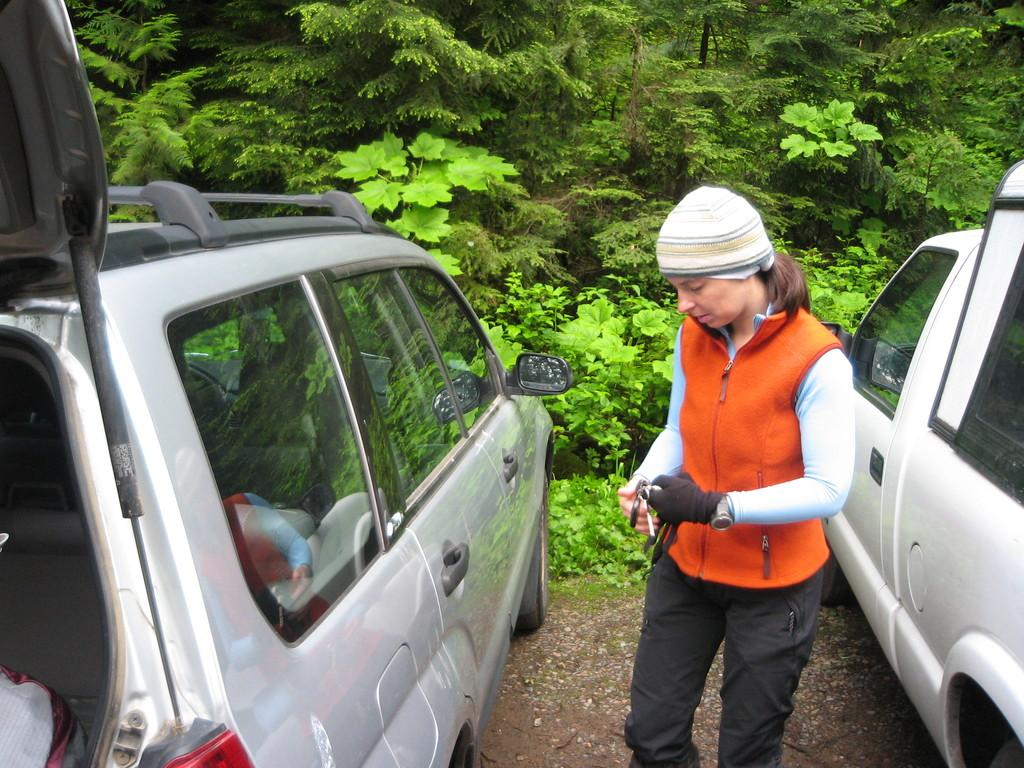Who is the main subject in the image? There is a woman standing in the front of the image. What else can be seen in the image besides the woman? There are cars in the image. What type of natural scenery is visible in the background? There are trees in the background of the image. What type of steel is used to construct the chess pieces in the image? There are no chess pieces present in the image, so it is not possible to determine the type of steel used. 